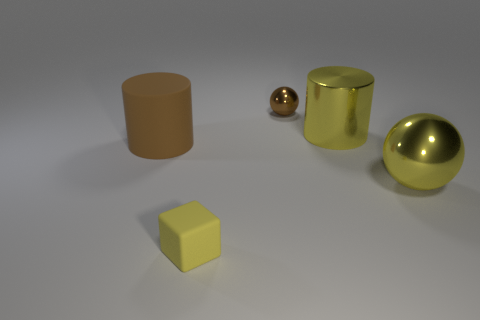What color is the small cube that is made of the same material as the large brown cylinder?
Give a very brief answer. Yellow. What number of tiny blue cylinders are made of the same material as the tiny brown sphere?
Provide a short and direct response. 0. What number of small green shiny objects are there?
Your answer should be compact. 0. There is a large thing that is in front of the matte cylinder; is its color the same as the large cylinder that is to the right of the tiny yellow rubber object?
Give a very brief answer. Yes. What number of brown objects are in front of the tiny brown thing?
Offer a very short reply. 1. There is a big cylinder that is the same color as the tiny matte object; what is its material?
Give a very brief answer. Metal. Is there a yellow thing of the same shape as the brown metal thing?
Ensure brevity in your answer.  Yes. Does the tiny thing that is behind the large yellow ball have the same material as the sphere on the right side of the brown metal ball?
Offer a very short reply. Yes. How big is the rubber object that is right of the brown thing left of the sphere to the left of the large yellow shiny sphere?
Make the answer very short. Small. What material is the brown thing that is the same size as the yellow metal sphere?
Offer a very short reply. Rubber. 